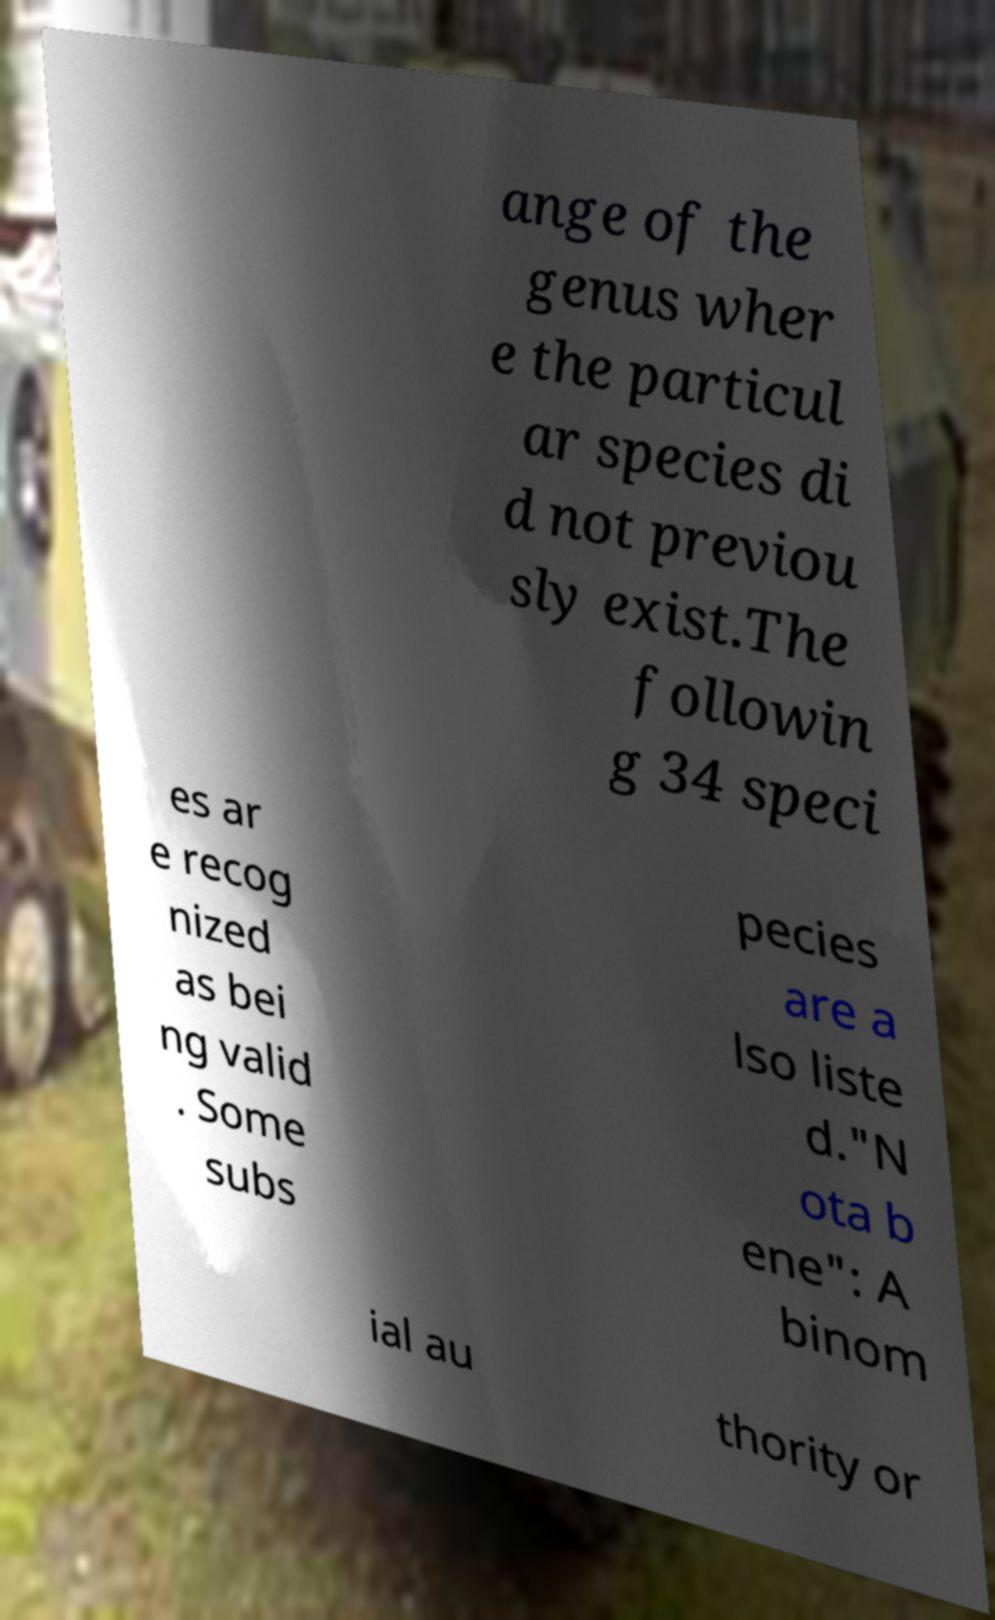There's text embedded in this image that I need extracted. Can you transcribe it verbatim? ange of the genus wher e the particul ar species di d not previou sly exist.The followin g 34 speci es ar e recog nized as bei ng valid . Some subs pecies are a lso liste d."N ota b ene": A binom ial au thority or 